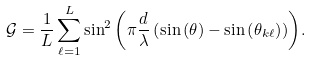<formula> <loc_0><loc_0><loc_500><loc_500>\mathcal { G } = \frac { 1 } { L } \sum _ { \ell = 1 } ^ { L } { \sin ^ { 2 } \left ( \pi \frac { d } { \lambda } \left ( \sin \left ( \theta \right ) - \sin \left ( \theta _ { k \ell } \right ) \right ) \right ) } .</formula> 